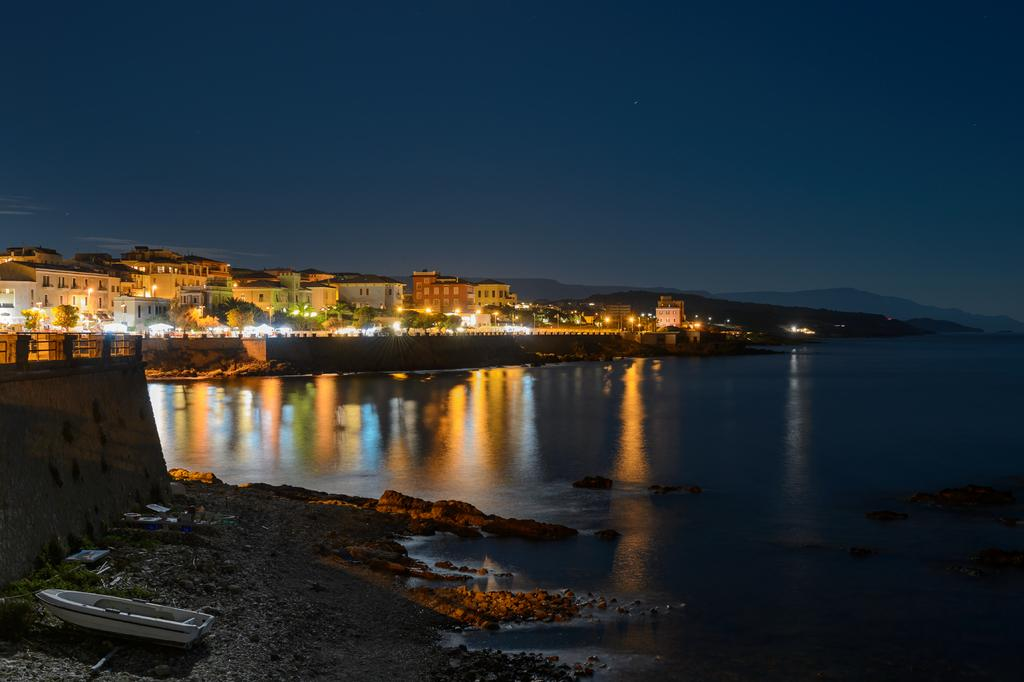What is the main feature of the image? There is water in the image. What is floating on the water? There is a boat in the image. What can be seen illuminating the scene? There are lights in the image. What type of vegetation is present in the image? There are trees in the image. What type of man-made structures are visible in the image? There are buildings in the image. What is visible at the top of the image? The sky is visible at the top of the image. What type of pancake is being served on the boat in the image? There is no pancake present in the image; it is a boat on water with lights, trees, and buildings in the background. What is the reason for the existence of the boat in the image? The image does not provide information about the reason for the existence of the boat; it simply shows a boat on water with lights, trees, and buildings in the background. 